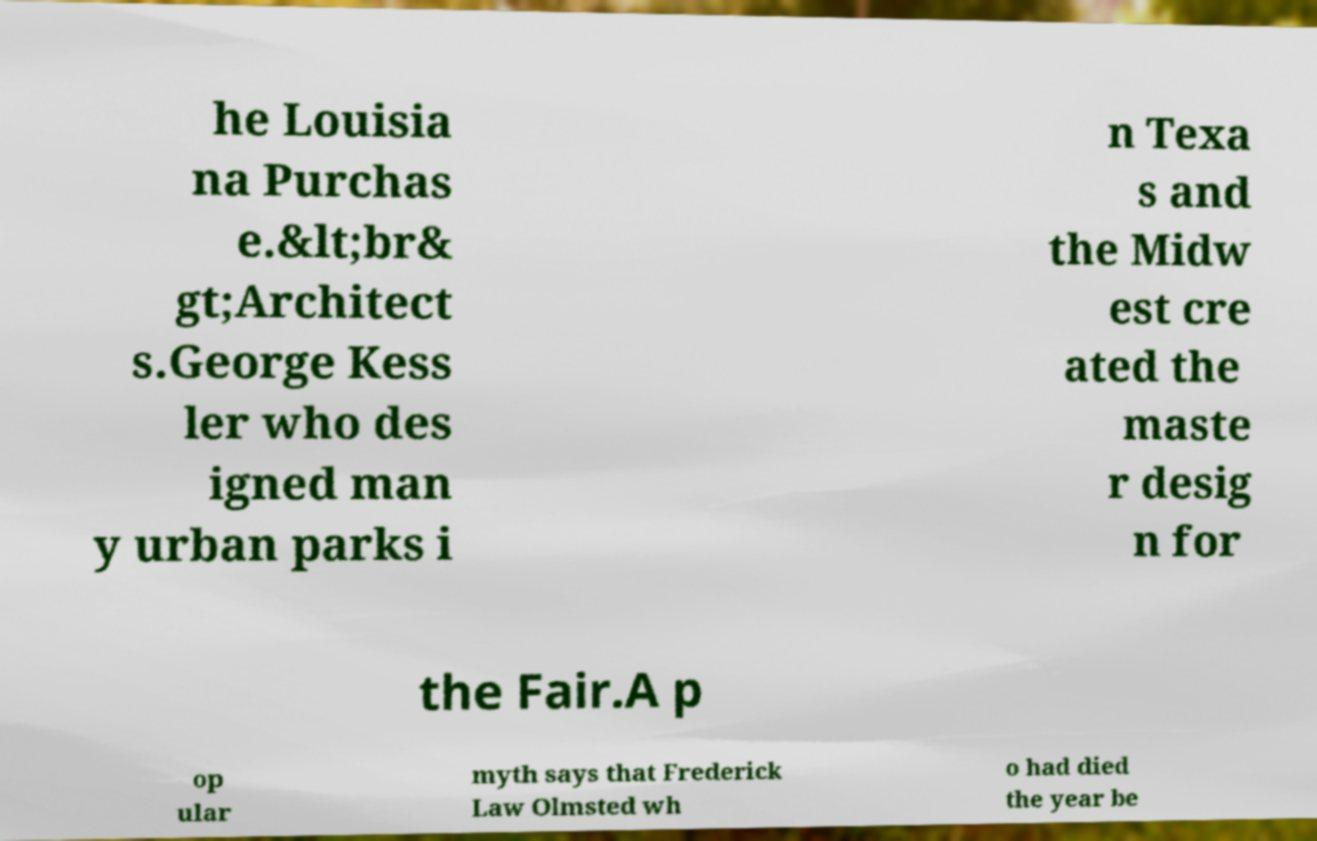Please identify and transcribe the text found in this image. he Louisia na Purchas e.&lt;br& gt;Architect s.George Kess ler who des igned man y urban parks i n Texa s and the Midw est cre ated the maste r desig n for the Fair.A p op ular myth says that Frederick Law Olmsted wh o had died the year be 